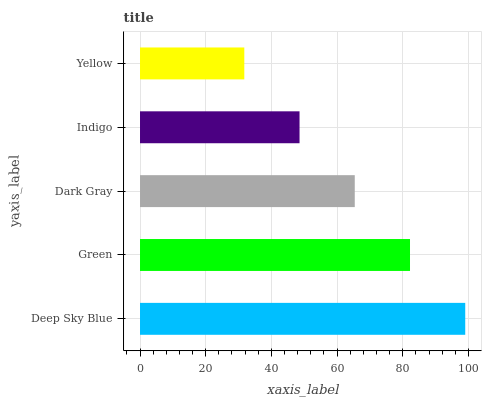Is Yellow the minimum?
Answer yes or no. Yes. Is Deep Sky Blue the maximum?
Answer yes or no. Yes. Is Green the minimum?
Answer yes or no. No. Is Green the maximum?
Answer yes or no. No. Is Deep Sky Blue greater than Green?
Answer yes or no. Yes. Is Green less than Deep Sky Blue?
Answer yes or no. Yes. Is Green greater than Deep Sky Blue?
Answer yes or no. No. Is Deep Sky Blue less than Green?
Answer yes or no. No. Is Dark Gray the high median?
Answer yes or no. Yes. Is Dark Gray the low median?
Answer yes or no. Yes. Is Deep Sky Blue the high median?
Answer yes or no. No. Is Green the low median?
Answer yes or no. No. 